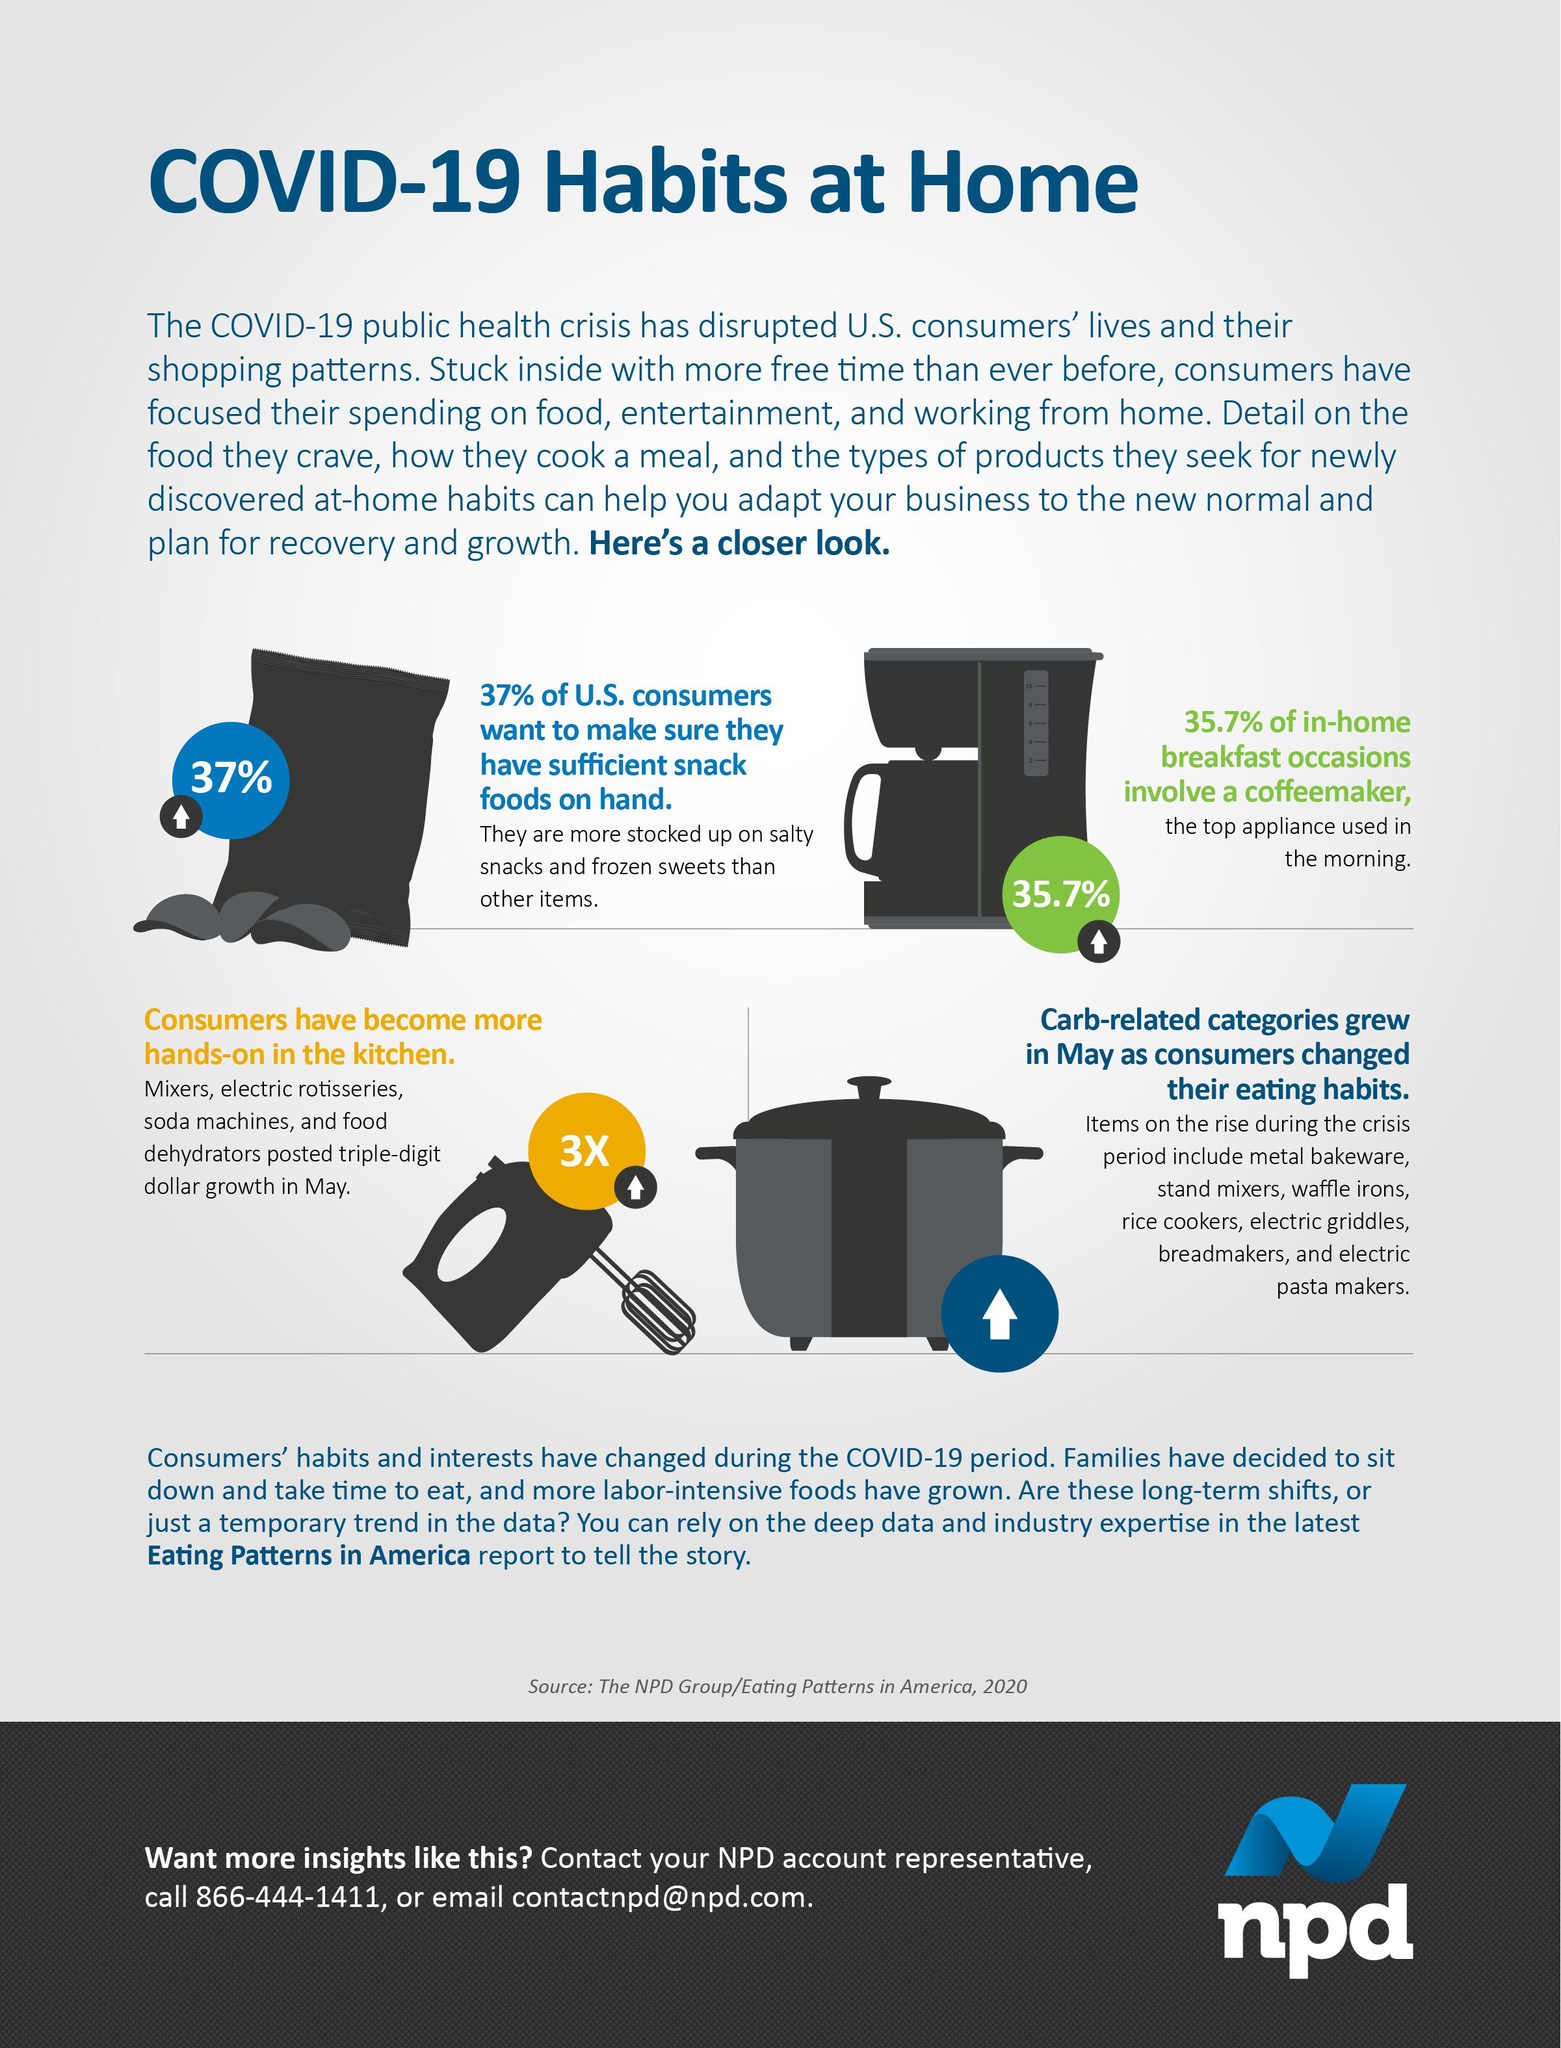Identify some key points in this picture. According to a survey of US consumers, 63% do not want to take the step of ensuring they have sufficient food on hand. According to a survey, 37% of U.S. consumers stocked up on snacks and food supplies in preparation for the pandemic. The total number of instances of the word "COVID-19" in the infographic is three. The percentage of in-home breakfast occasions that do not involve a coffeemaker is 64.3%. 